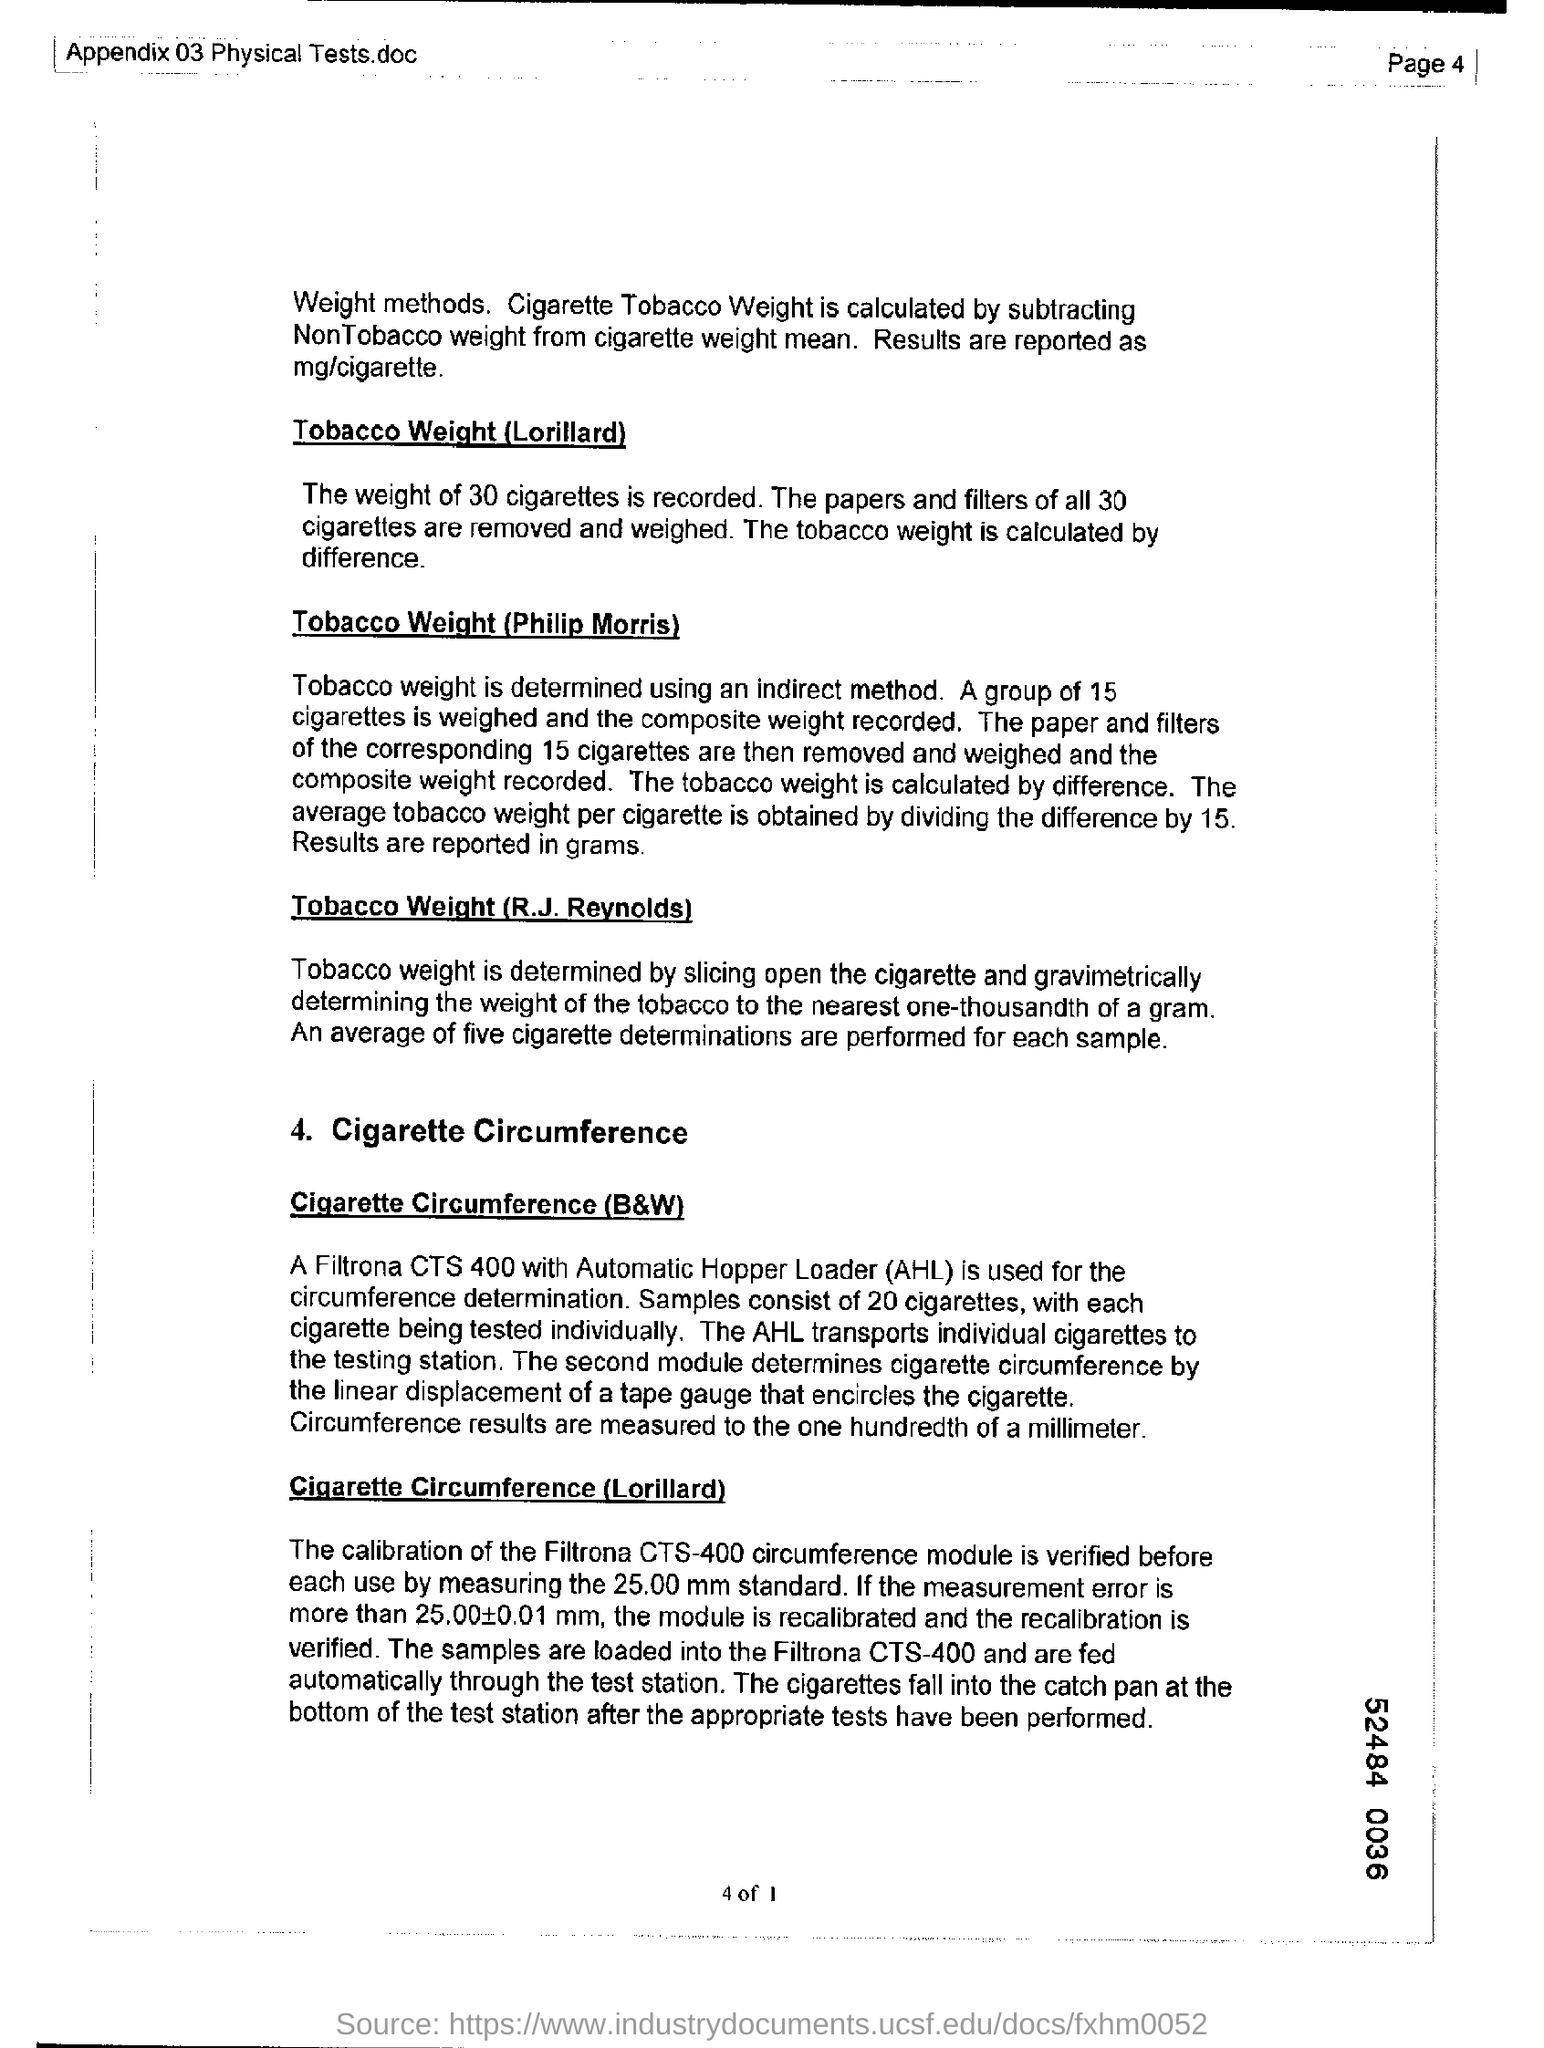Give some essential details in this illustration. The Automatic Hopper Loader, referred to as AHL, is a machine designed for efficient and automatic loading of materials into a process or production system. Page 4 is what I am looking for. 